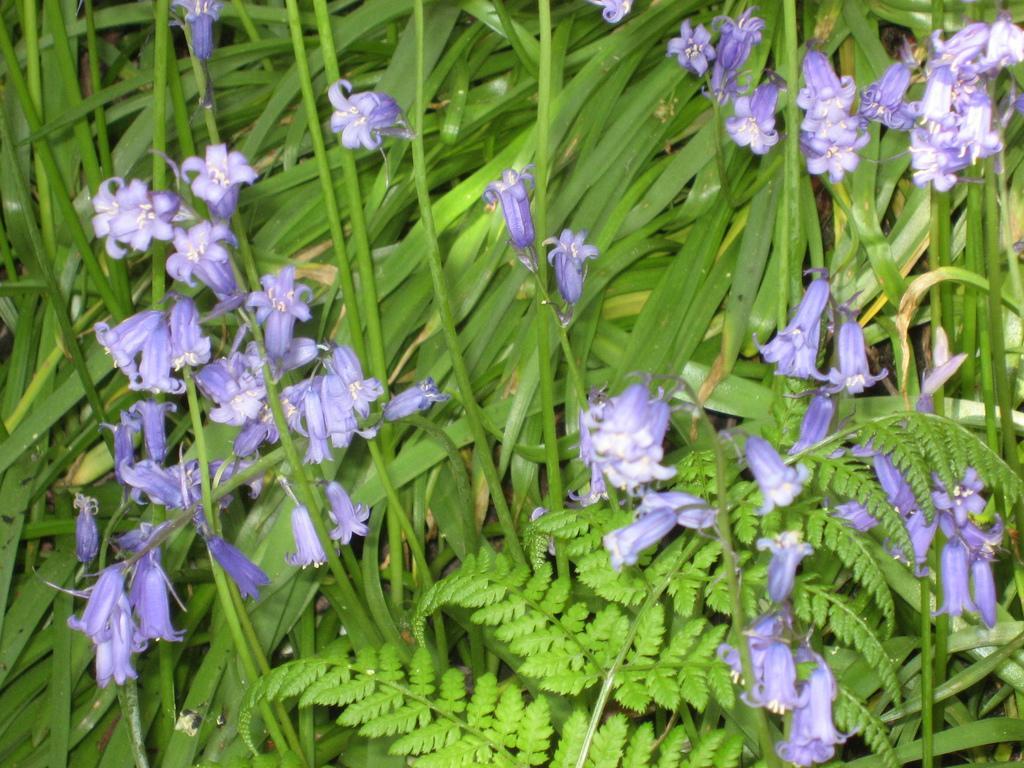Describe this image in one or two sentences. In this picture there are purple color flowers on the plants and there are two different types of plants. 